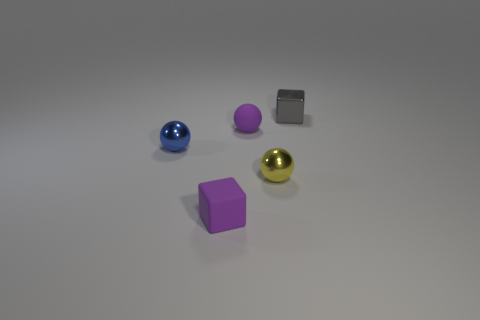Add 5 cylinders. How many objects exist? 10 Subtract all small blue spheres. How many spheres are left? 2 Subtract all balls. How many objects are left? 2 Subtract 3 spheres. How many spheres are left? 0 Subtract all yellow balls. How many balls are left? 2 Subtract all purple blocks. Subtract all cyan cylinders. How many blocks are left? 1 Subtract all purple blocks. How many purple spheres are left? 1 Subtract all tiny gray blocks. Subtract all tiny yellow balls. How many objects are left? 3 Add 5 tiny gray metal blocks. How many tiny gray metal blocks are left? 6 Add 3 large blue rubber objects. How many large blue rubber objects exist? 3 